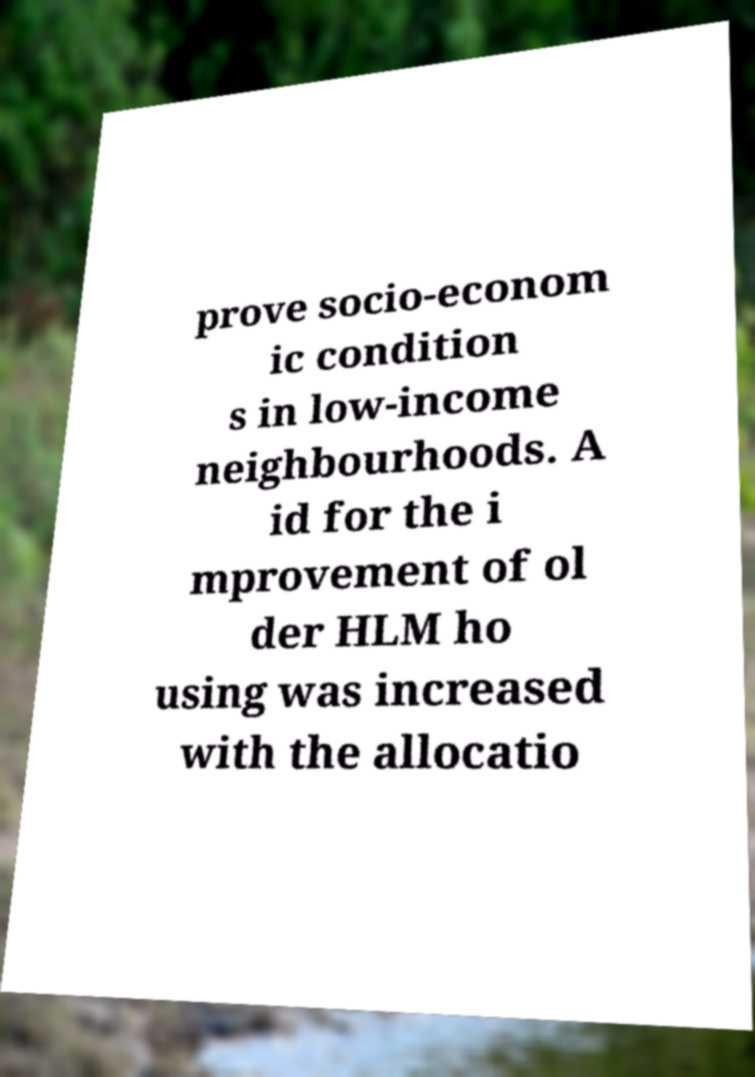For documentation purposes, I need the text within this image transcribed. Could you provide that? prove socio-econom ic condition s in low-income neighbourhoods. A id for the i mprovement of ol der HLM ho using was increased with the allocatio 